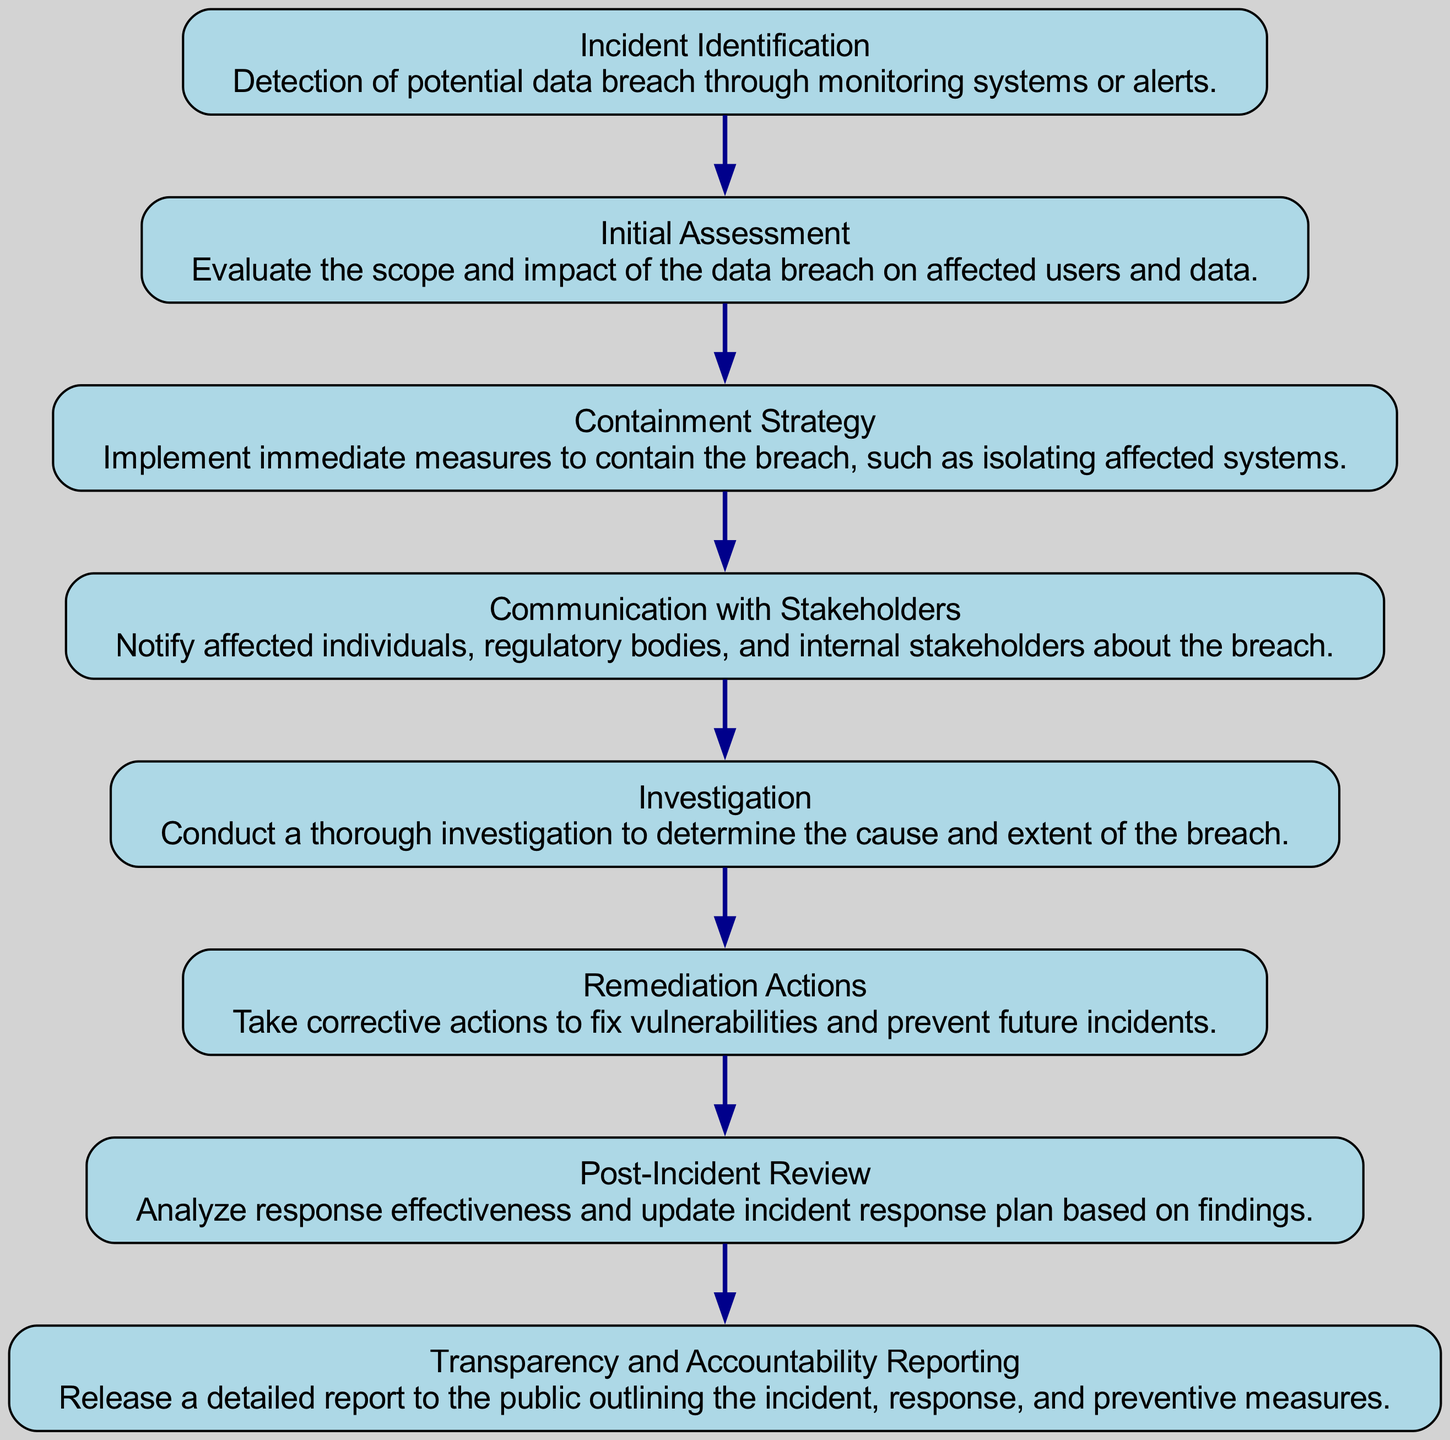What is the first step in the incident response process flow? The first step is "Incident Identification." This is derived from the top node of the flow chart which indicates the starting point of the process.
Answer: Incident Identification How many total steps are in the incident response process? Counting each node in the flow chart, there are 8 steps, starting from "Incident Identification" to "Transparency and Accountability Reporting."
Answer: 8 What action follows after the "Containment Strategy"? The action that directly follows "Containment Strategy" is "Communication with Stakeholders." This can be determined by the flow of arrows connecting the nodes in the diagram.
Answer: Communication with Stakeholders Which step focuses on analyzing the response effectiveness? The step that focuses on analyzing the response effectiveness is "Post-Incident Review." This is explicitly mentioned as part of the description of that node.
Answer: Post-Incident Review What is the main goal of the "Remediation Actions" step? The goal of "Remediation Actions" is to take corrective actions to fix vulnerabilities and prevent future incidents, as indicated in its description.
Answer: Fix vulnerabilities How many actions are taken after the "Investigation" step? After "Investigation," there are two actions: "Remediation Actions" and then "Post-Incident Review." The flow chart connects these nodes sequentially, indicating that both actions follow "Investigation."
Answer: 2 What type of report is released in the final step? The report released in the final step is referred to as a "detailed report." This information is clearly stated in the description of the last node in the flow chart.
Answer: Detailed report What key stakeholder is notified during the incident response process? During the process, "affected individuals" are among the key stakeholders notified, as mentioned in the description of "Communication with Stakeholders."
Answer: Affected individuals Which step directly involves assessing the impact on users? The step that directly involves assessing the impact on users is "Initial Assessment." This is highlighted in the flow chart, indicating its focus area.
Answer: Initial Assessment 